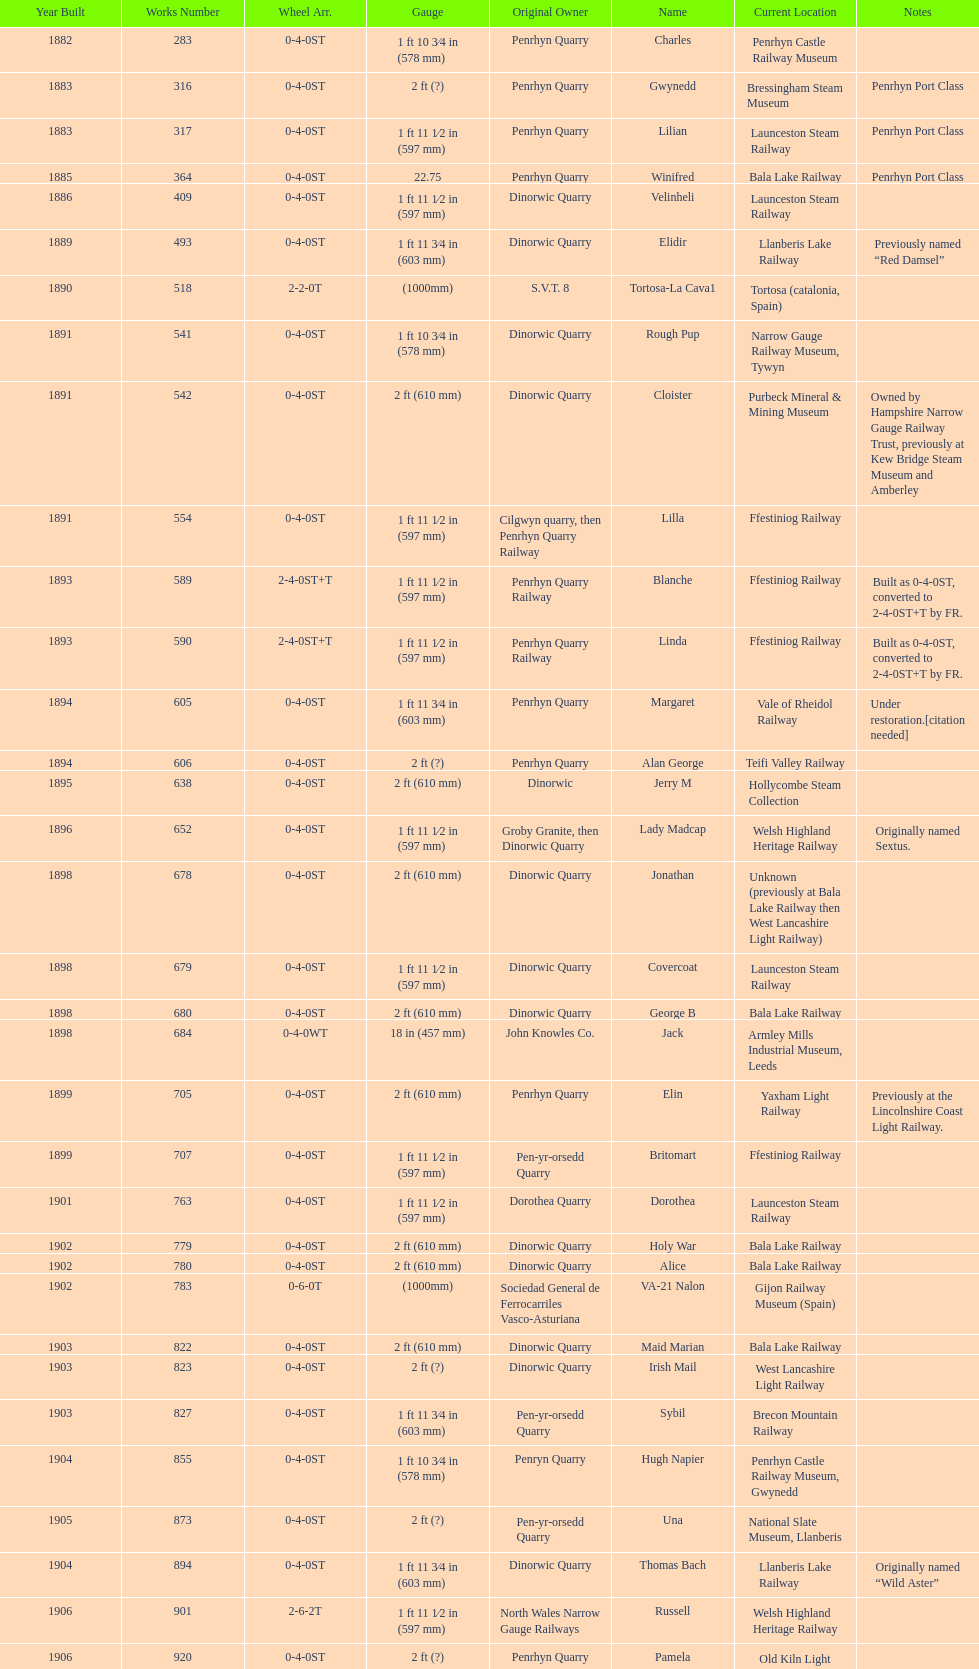Who was the owner of the most recent locomotive to be constructed? Trangkil Sugar Mill, Indonesia. 